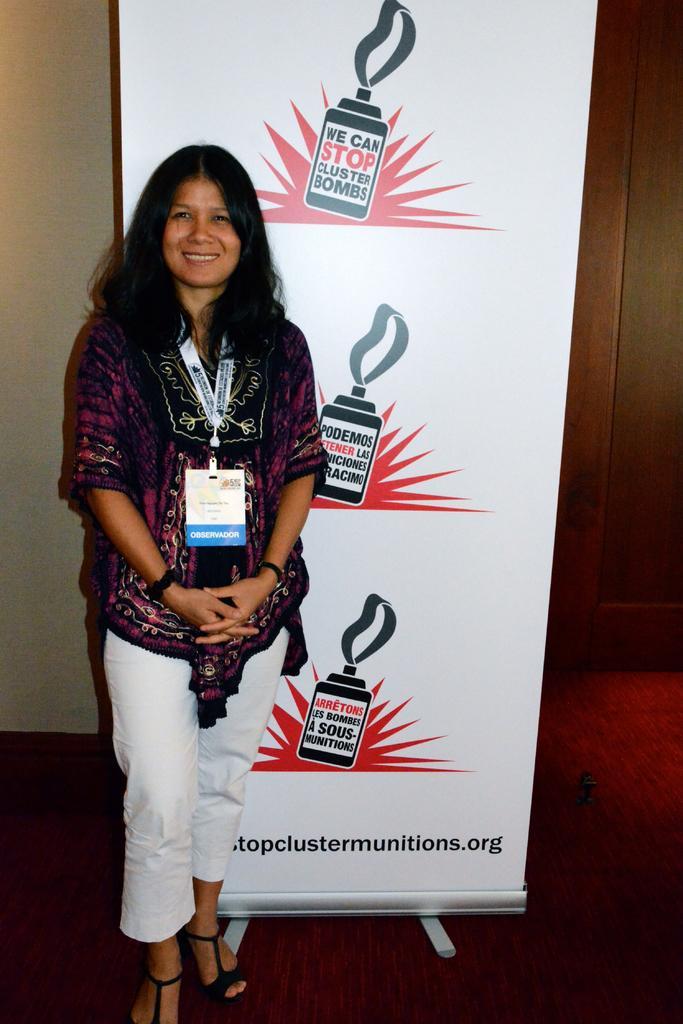Describe this image in one or two sentences. Here we can see a woman standing on the floor at the hoarding and she wore a ID card on her neck and this is wall. 